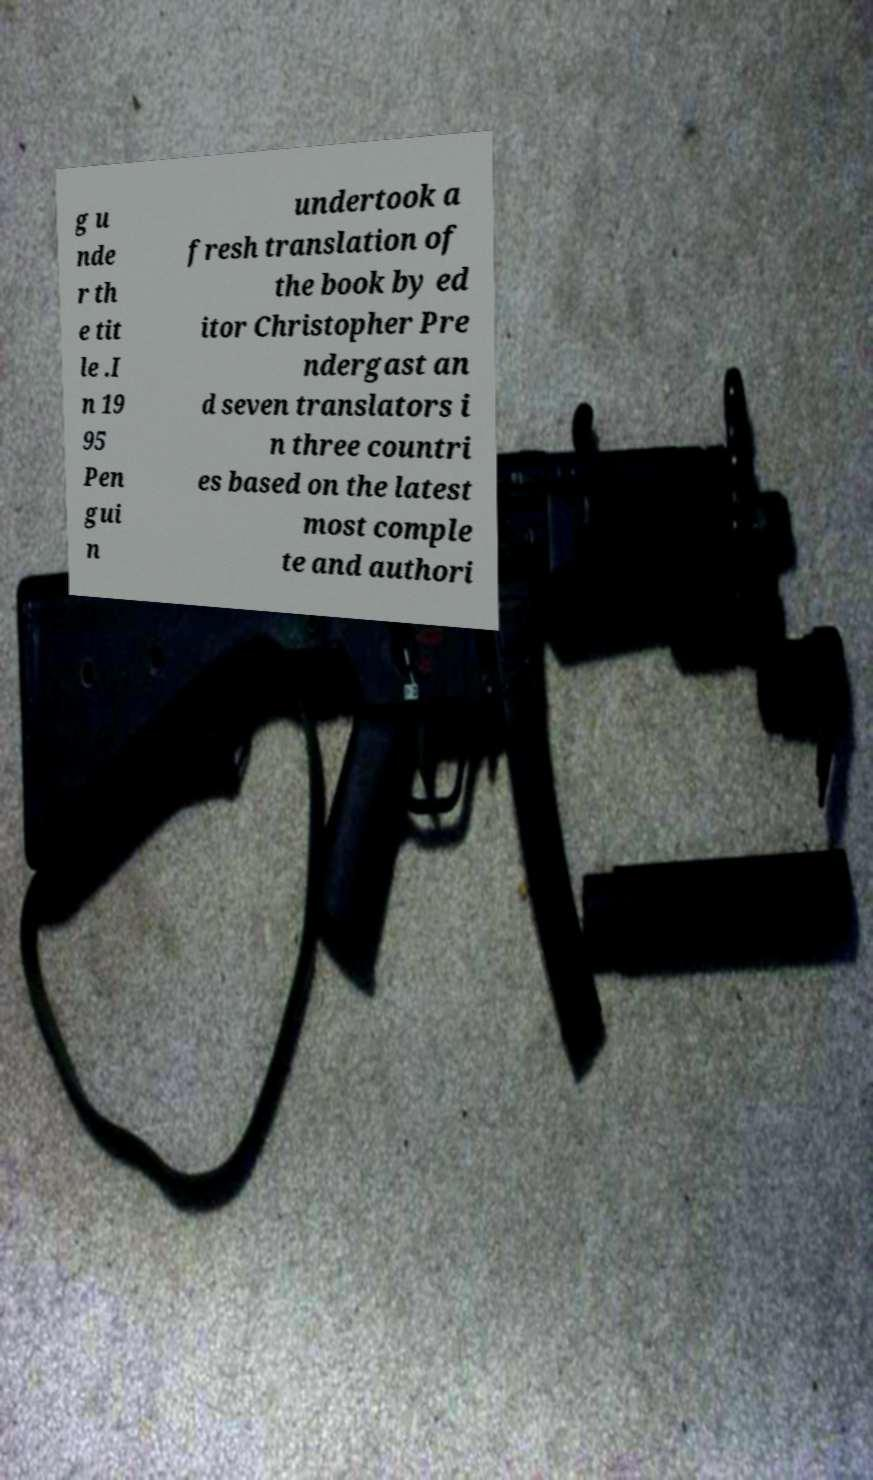Can you accurately transcribe the text from the provided image for me? g u nde r th e tit le .I n 19 95 Pen gui n undertook a fresh translation of the book by ed itor Christopher Pre ndergast an d seven translators i n three countri es based on the latest most comple te and authori 